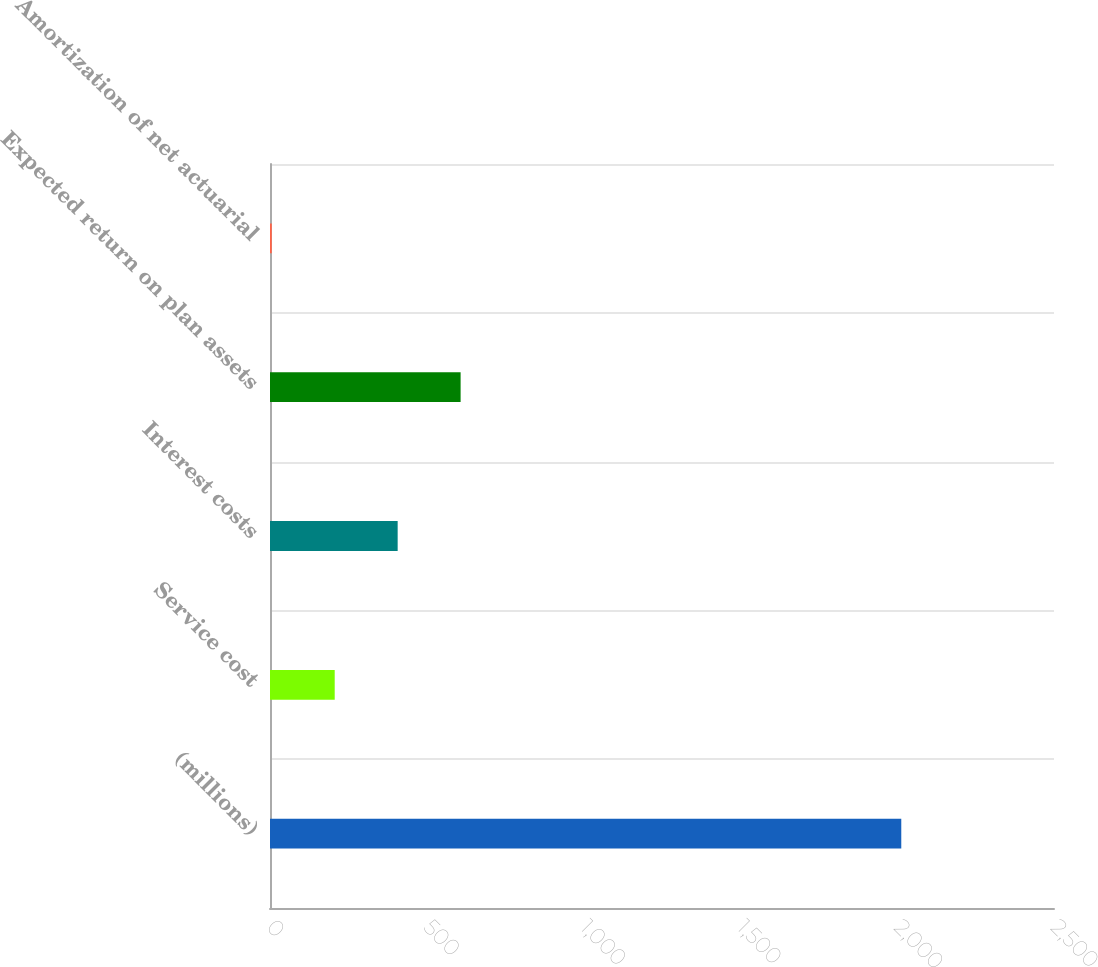Convert chart to OTSL. <chart><loc_0><loc_0><loc_500><loc_500><bar_chart><fcel>(millions)<fcel>Service cost<fcel>Interest costs<fcel>Expected return on plan assets<fcel>Amortization of net actuarial<nl><fcel>2013<fcel>206.34<fcel>407.08<fcel>607.82<fcel>5.6<nl></chart> 